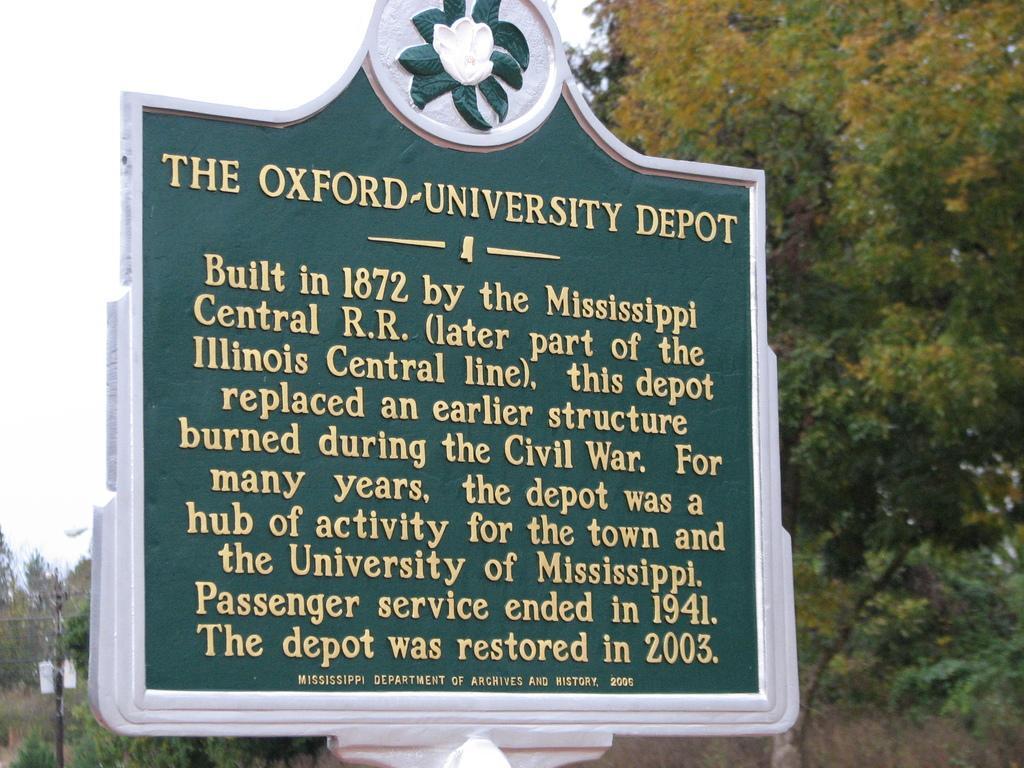Could you give a brief overview of what you see in this image? In this image we see a board which consists of some text on it, and in the background there are trees and a current pole. 